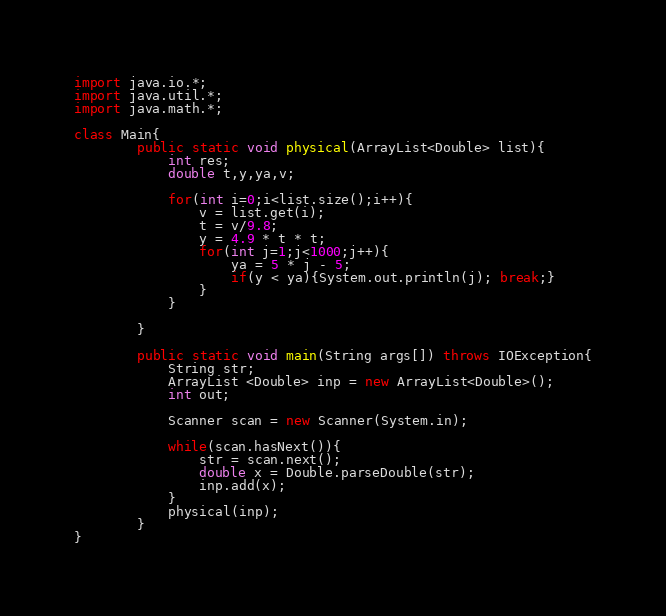<code> <loc_0><loc_0><loc_500><loc_500><_Java_>import java.io.*;
import java.util.*;
import java.math.*;

class Main{
		public static void physical(ArrayList<Double> list){
			int res;
			double t,y,ya,v;
			
			for(int i=0;i<list.size();i++){
				v = list.get(i);
				t = v/9.8;
				y = 4.9 * t * t;
				for(int j=1;j<1000;j++){
					ya = 5 * j - 5;
					if(y < ya){System.out.println(j); break;}
				}
			}
			
		}
		
		public static void main(String args[]) throws IOException{
			String str;
			ArrayList <Double> inp = new ArrayList<Double>();
			int out;

			Scanner scan = new Scanner(System.in);
			
			while(scan.hasNext()){
				str = scan.next();
				double x = Double.parseDouble(str);
				inp.add(x);
			}
			physical(inp);
		}
}</code> 